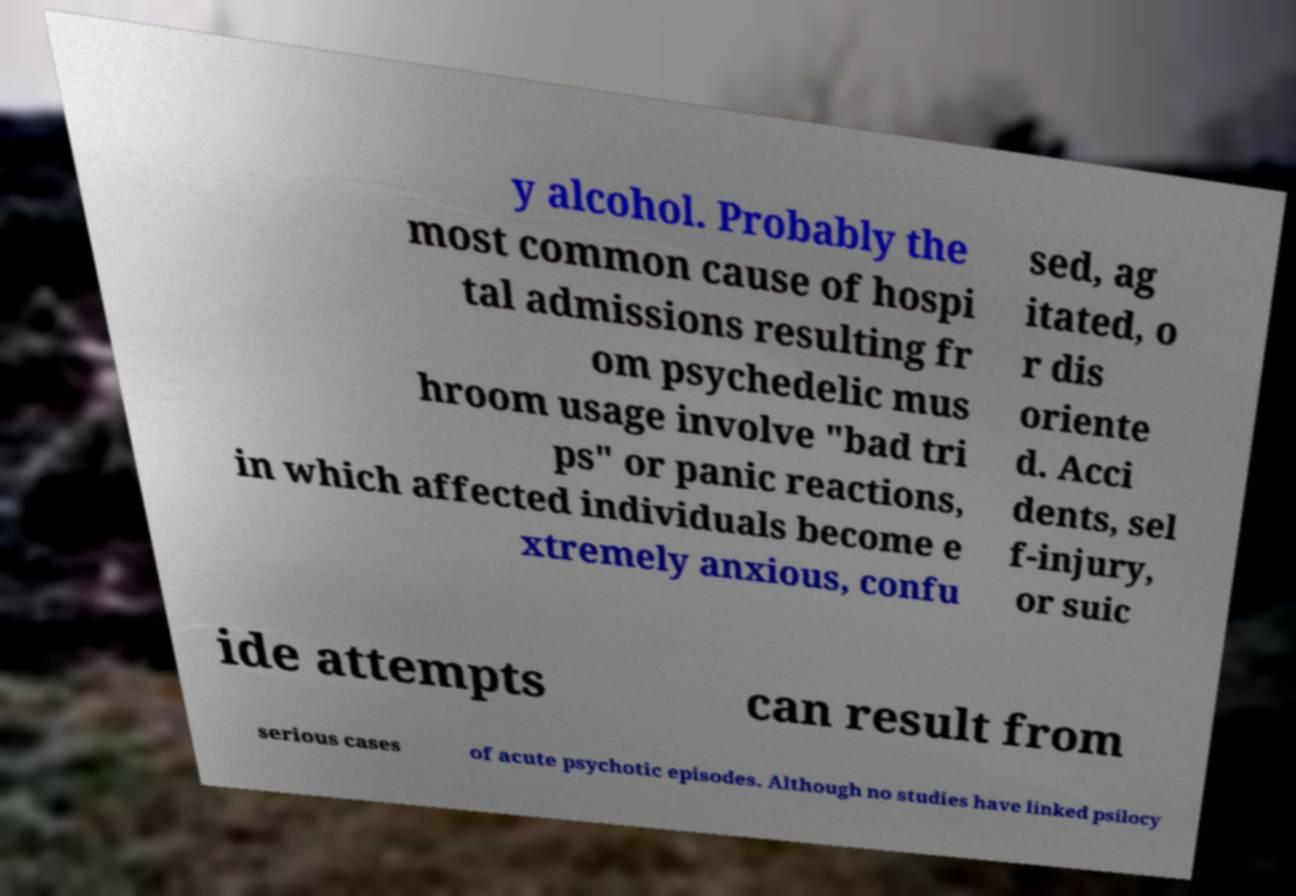Can you read and provide the text displayed in the image?This photo seems to have some interesting text. Can you extract and type it out for me? y alcohol. Probably the most common cause of hospi tal admissions resulting fr om psychedelic mus hroom usage involve "bad tri ps" or panic reactions, in which affected individuals become e xtremely anxious, confu sed, ag itated, o r dis oriente d. Acci dents, sel f-injury, or suic ide attempts can result from serious cases of acute psychotic episodes. Although no studies have linked psilocy 